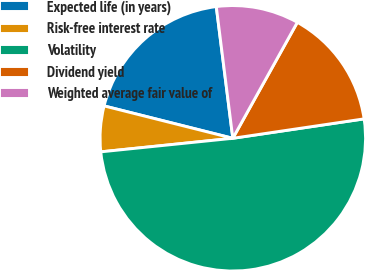<chart> <loc_0><loc_0><loc_500><loc_500><pie_chart><fcel>Expected life (in years)<fcel>Risk-free interest rate<fcel>Volatility<fcel>Dividend yield<fcel>Weighted average fair value of<nl><fcel>19.09%<fcel>5.55%<fcel>50.71%<fcel>14.58%<fcel>10.07%<nl></chart> 